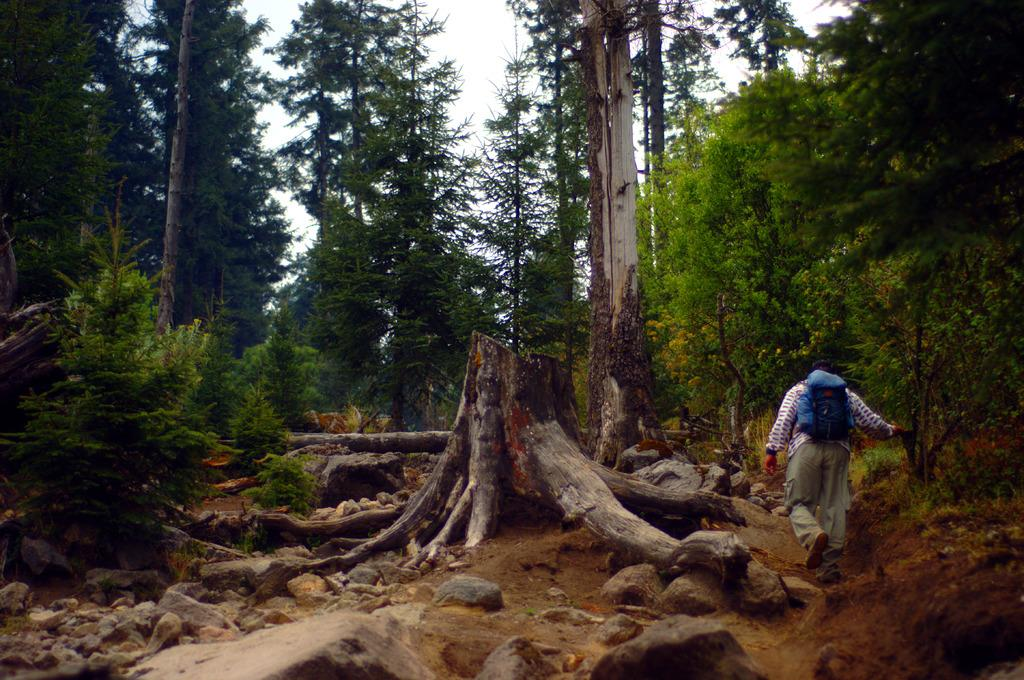What is present in the image? There is a person, a tree trunk, stones, a plant, trees, and the sky visible in the image. What is the person wearing? The person is wearing clothes and shoes. What is the person doing with the bag? The person is hanging a bag on his back. What type of thread is being used to create the marble sculpture in the image? There is no marble sculpture present in the image, so it is not possible to determine what type of thread might be used. --- Facts: 1. There is a car in the image. 2. The car is red. 3. The car has four wheels. 4. There is a road in the image. 5. The road is paved. 6. There are trees on the side of the road. 7. The sky is visible in the image. Absurd Topics: fish, piano, ocean Conversation: What is the color of the car in the image? The car is red. How many wheels does the car have? The car has four wheels. What is the surface of the road in the image? The road is paved. What type of vegetation is on the side of the road? There are trees on the side of the road. What is visible at the top of the image? The sky is visible in the image. Reasoning: Let's think step by step in order to produce the conversation. We start by identifying the main subject in the image, which is the car. Then, we expand the conversation to include other items that are also visible, such as the road, trees, and the sky. We also describe the car's color and number of wheels. Each question is designed to elicit a specific detail about the image that is known from the provided facts. Absurd Question/Answer: Can you see any fish swimming in the ocean in the image? There is no ocean or fish present in the image. What type of piano can be heard playing in the background of the image? There is no piano or sound present in the image. 